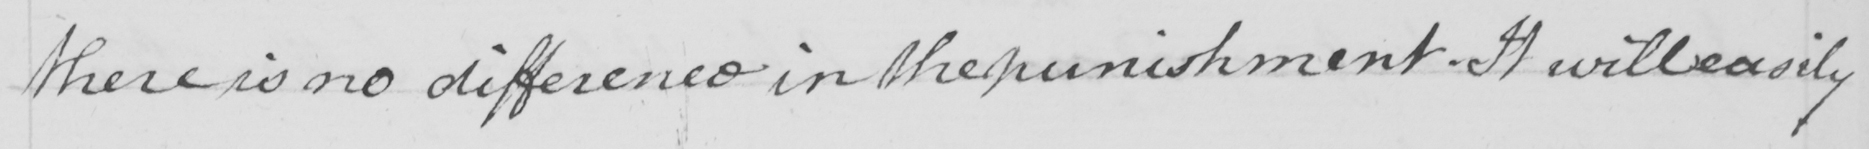What does this handwritten line say? there is no difference in the punishment . It will easily 